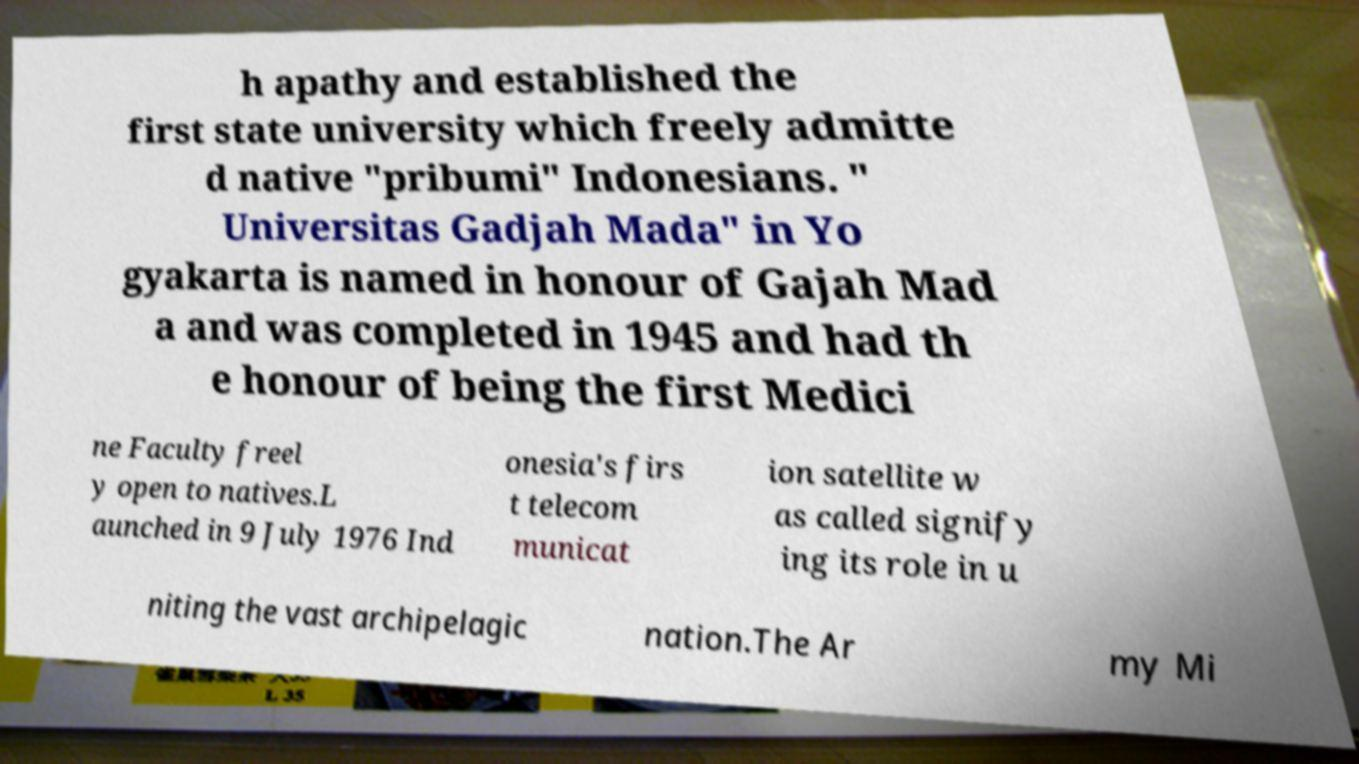Can you read and provide the text displayed in the image?This photo seems to have some interesting text. Can you extract and type it out for me? h apathy and established the first state university which freely admitte d native "pribumi" Indonesians. " Universitas Gadjah Mada" in Yo gyakarta is named in honour of Gajah Mad a and was completed in 1945 and had th e honour of being the first Medici ne Faculty freel y open to natives.L aunched in 9 July 1976 Ind onesia's firs t telecom municat ion satellite w as called signify ing its role in u niting the vast archipelagic nation.The Ar my Mi 